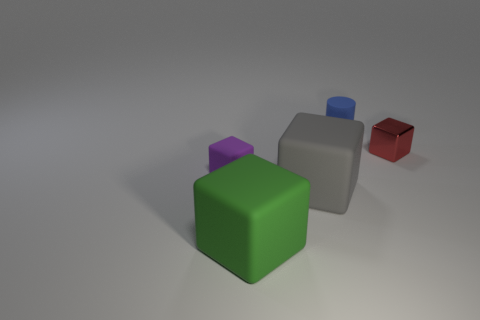Can you describe the colors and arrangement of the cubes in this image? Certainly! In the image, there are five cubes. Starting from the foreground and moving towards the background, the colors are green, purple, gray, blue, and red. The cubes are arranged in a staggered formation with each subsequent cube placed slightly further away and to the right from the one in front of it. 